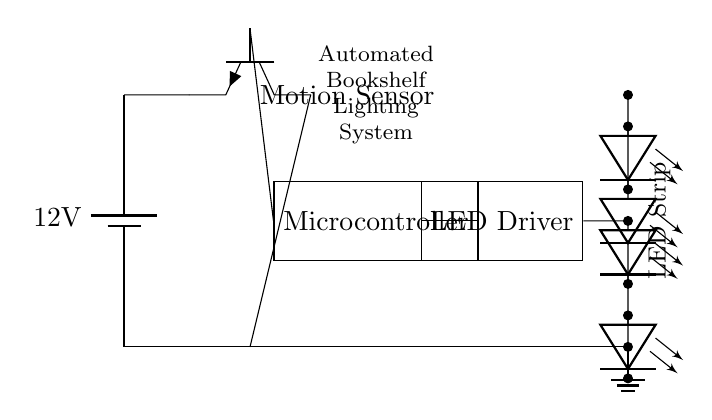What is the voltage supply in this circuit? The voltage supply is 12 volts, as indicated by the battery symbol labeled with the voltage value in the circuit diagram.
Answer: 12 volts What component detects motion in this circuit? The motion sensor component is marked clearly in the circuit diagram as "Motion Sensor," and it connects to both the power supply and the microcontroller.
Answer: Motion Sensor How many LED strips are connected in this circuit? The circuit diagram illustrates four LED strips arranged in series, each denoted with the LED symbol, showing their physical configuration as part of the lighting system.
Answer: Four What is the role of the microcontroller? The microcontroller processes the signal from the motion sensor and controls the LED driver accordingly, facilitating the automation of the lighting system as portrayed by its connections in the circuit.
Answer: Control automation What connects the microcontroller and the LED driver? The connection between the microcontroller and the LED driver is a direct wire, as shown in the diagram where the east side of the microcontroller connects to the west side of the LED driver.
Answer: Wire connection What is the output of the LED driver in this circuit? The LED driver provides power to the LED strips, ensuring they illuminate when motion is detected by transferring energy from the microcontroller through its direct wiring shown in the circuit.
Answer: Power to LED strips 